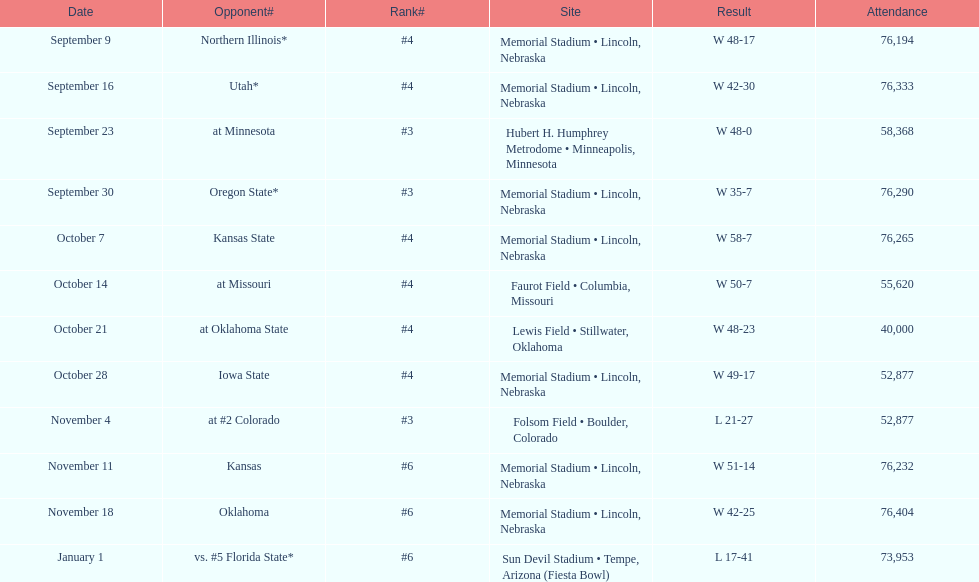On average how many times was w listed as the result? 10. 